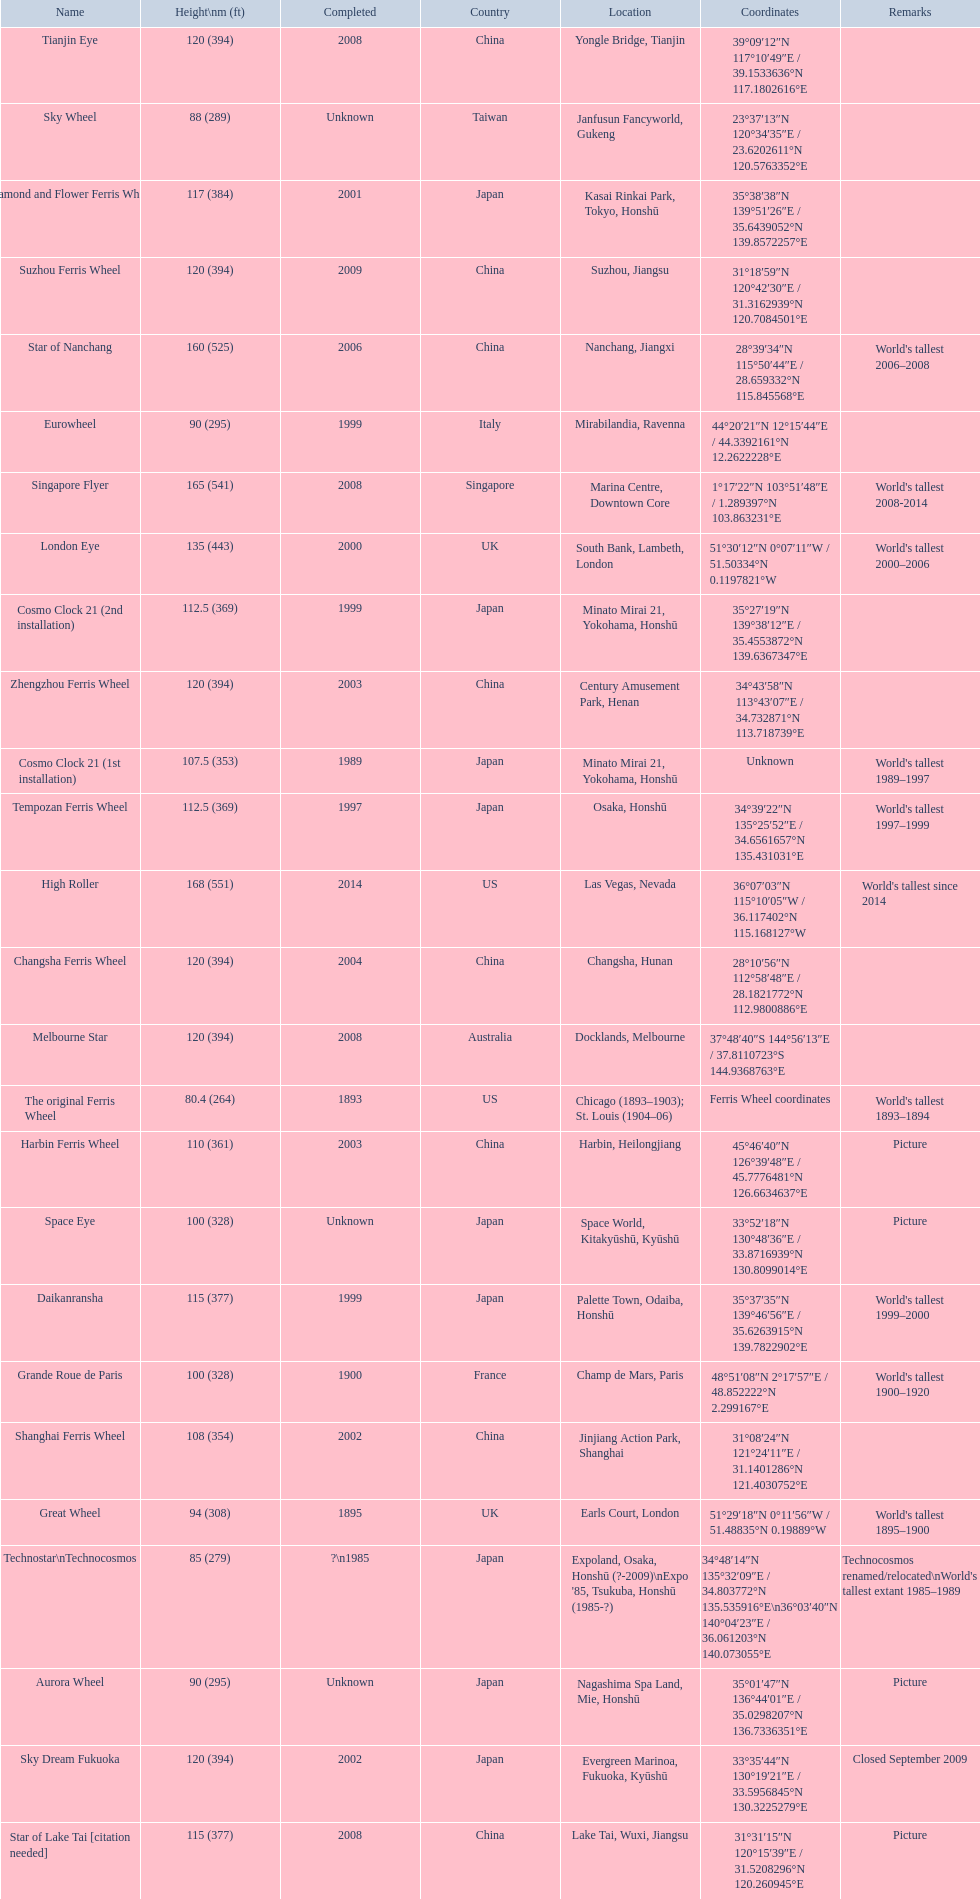When was the high roller ferris wheel completed? 2014. Which ferris wheel was completed in 2006? Star of Nanchang. Which one was completed in 2008? Singapore Flyer. 